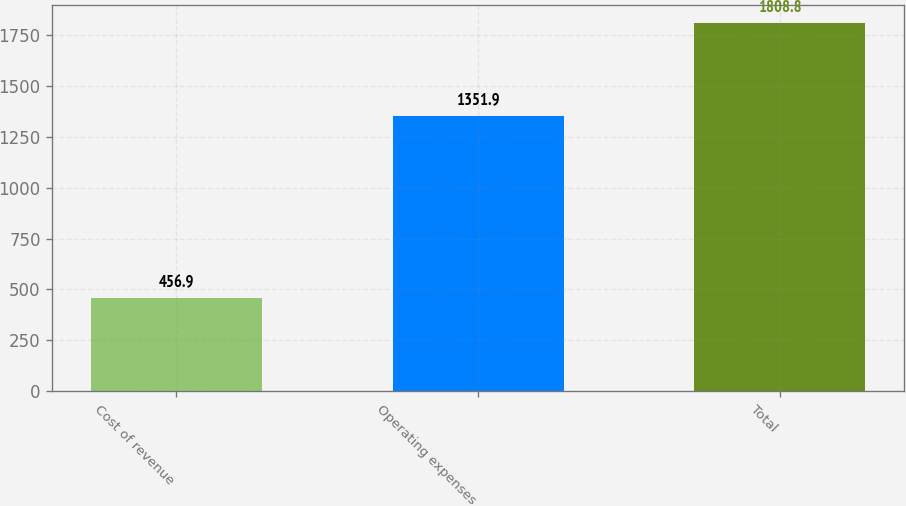Convert chart to OTSL. <chart><loc_0><loc_0><loc_500><loc_500><bar_chart><fcel>Cost of revenue<fcel>Operating expenses<fcel>Total<nl><fcel>456.9<fcel>1351.9<fcel>1808.8<nl></chart> 